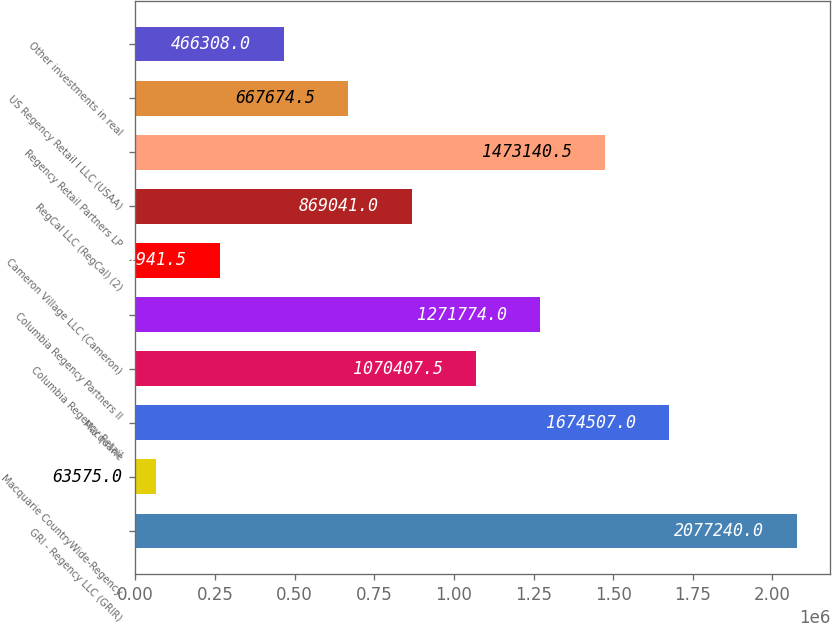Convert chart. <chart><loc_0><loc_0><loc_500><loc_500><bar_chart><fcel>GRI - Regency LLC (GRIR)<fcel>Macquarie CountryWide-Regency<fcel>Macquarie<fcel>Columbia Regency Retail<fcel>Columbia Regency Partners II<fcel>Cameron Village LLC (Cameron)<fcel>RegCal LLC (RegCal) (2)<fcel>Regency Retail Partners LP<fcel>US Regency Retail I LLC (USAA)<fcel>Other investments in real<nl><fcel>2.07724e+06<fcel>63575<fcel>1.67451e+06<fcel>1.07041e+06<fcel>1.27177e+06<fcel>264942<fcel>869041<fcel>1.47314e+06<fcel>667674<fcel>466308<nl></chart> 